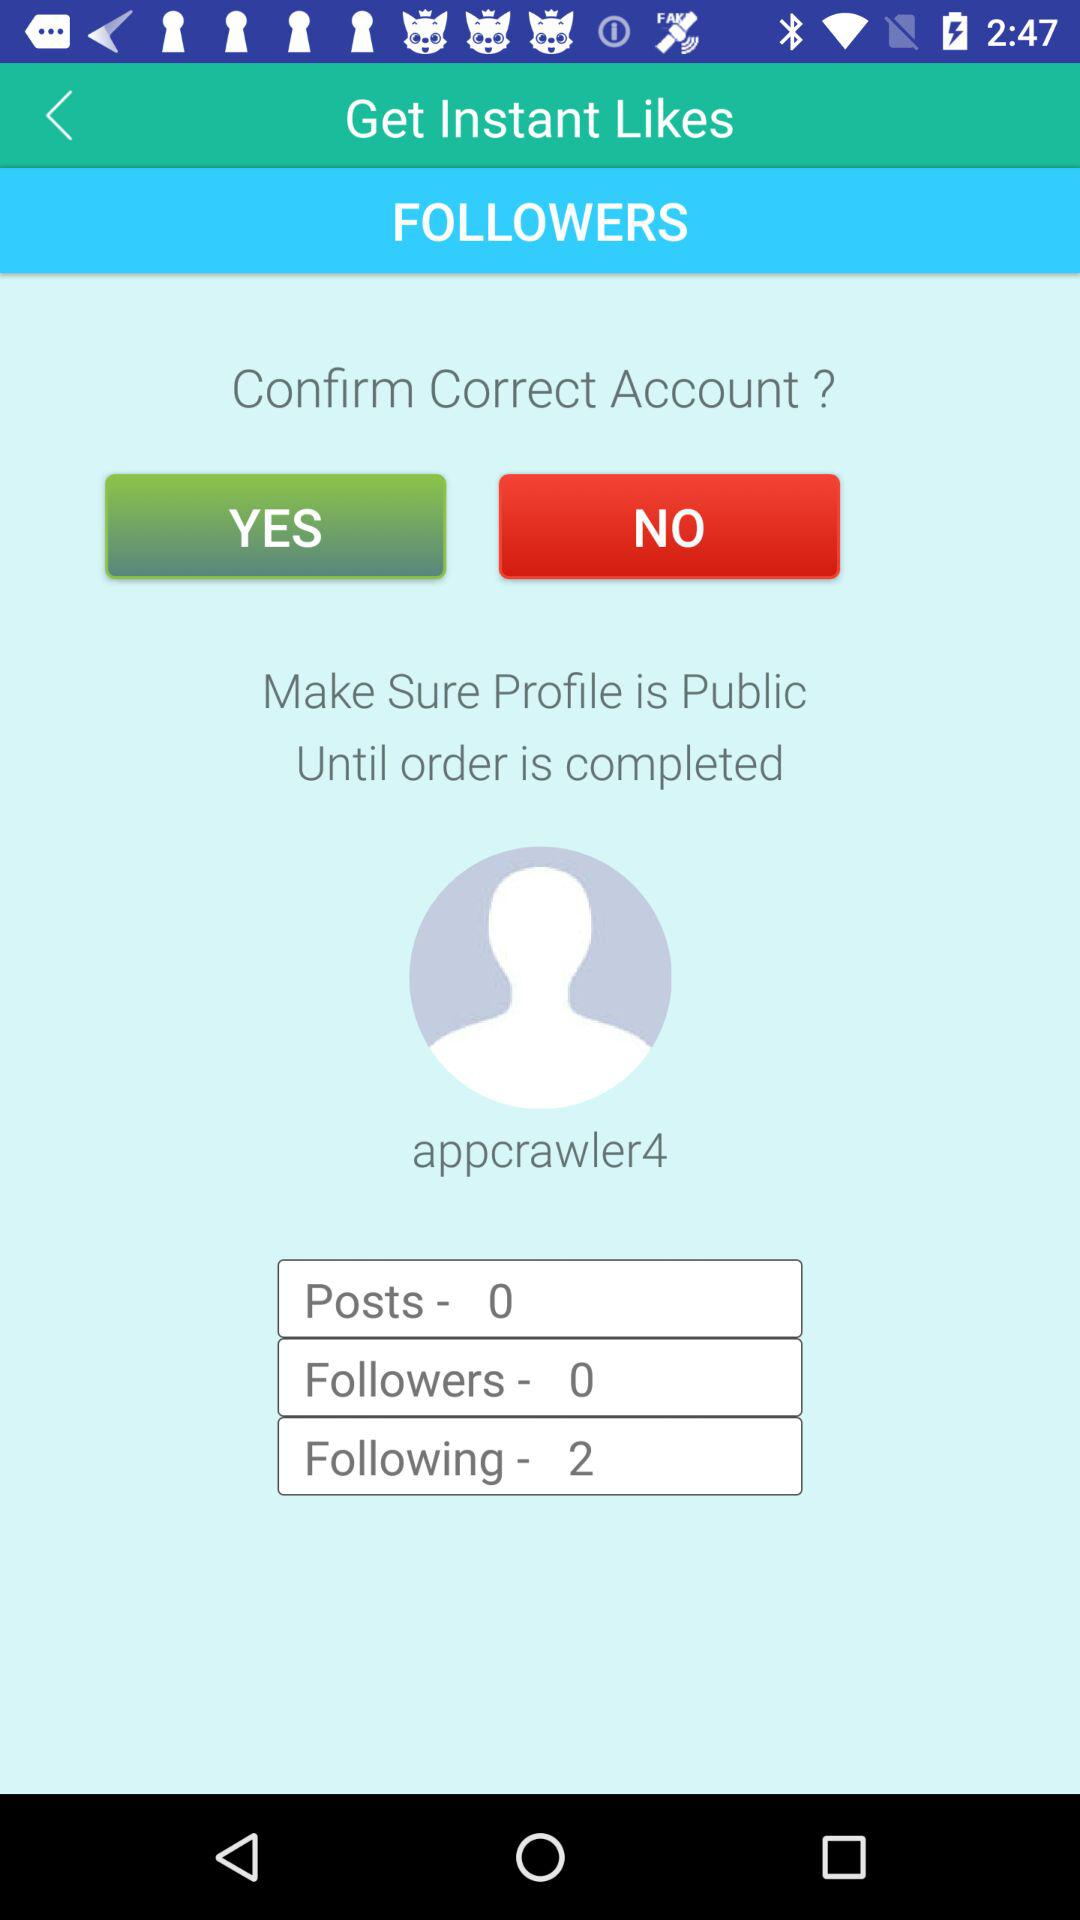What is the name of the user? The name of the user is Appcrawler4. 